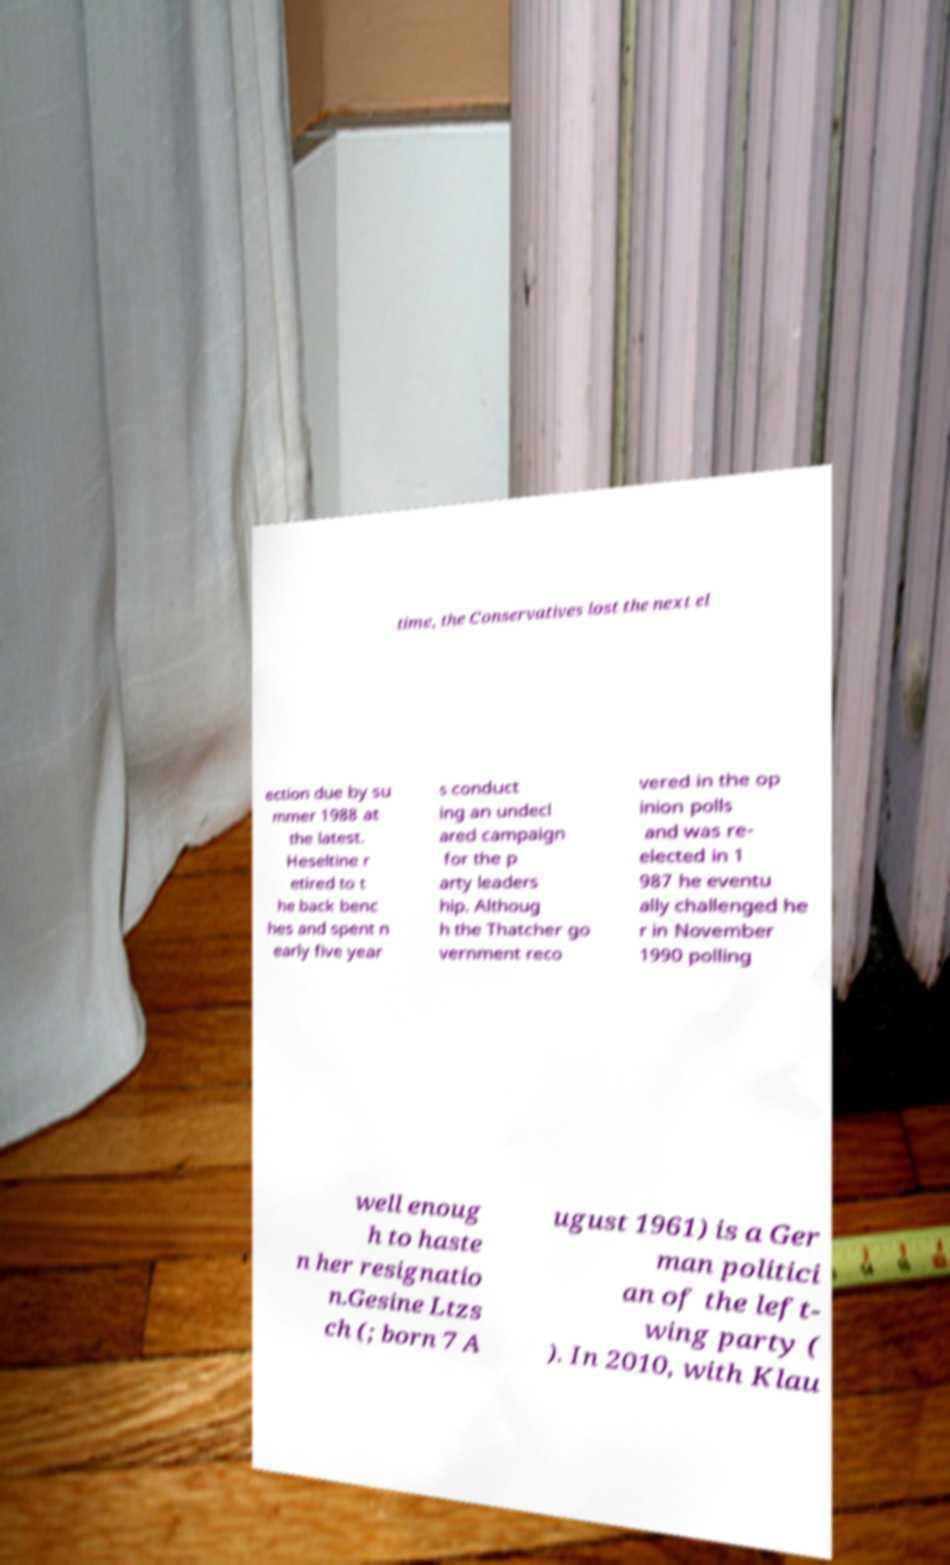Please identify and transcribe the text found in this image. time, the Conservatives lost the next el ection due by su mmer 1988 at the latest. Heseltine r etired to t he back benc hes and spent n early five year s conduct ing an undecl ared campaign for the p arty leaders hip. Althoug h the Thatcher go vernment reco vered in the op inion polls and was re- elected in 1 987 he eventu ally challenged he r in November 1990 polling well enoug h to haste n her resignatio n.Gesine Ltzs ch (; born 7 A ugust 1961) is a Ger man politici an of the left- wing party ( ). In 2010, with Klau 